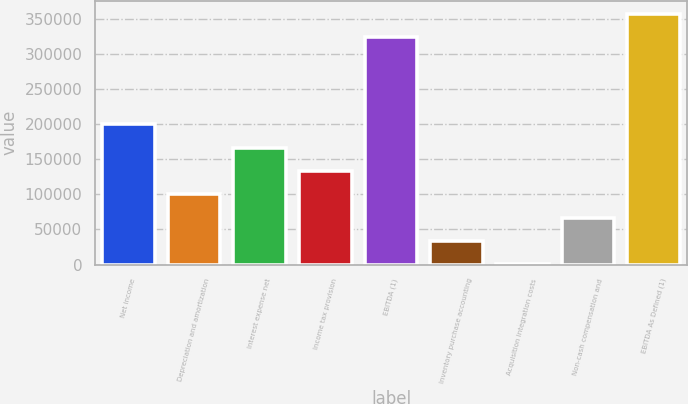<chart> <loc_0><loc_0><loc_500><loc_500><bar_chart><fcel>Net income<fcel>Depreciation and amortization<fcel>Interest expense net<fcel>Income tax provision<fcel>EBITDA (1)<fcel>Inventory purchase accounting<fcel>Acquisition integration costs<fcel>Non-cash compensation and<fcel>EBITDA As Defined (1)<nl><fcel>200003<fcel>100198<fcel>166735<fcel>133467<fcel>324533<fcel>33661.4<fcel>393<fcel>66929.8<fcel>357801<nl></chart> 